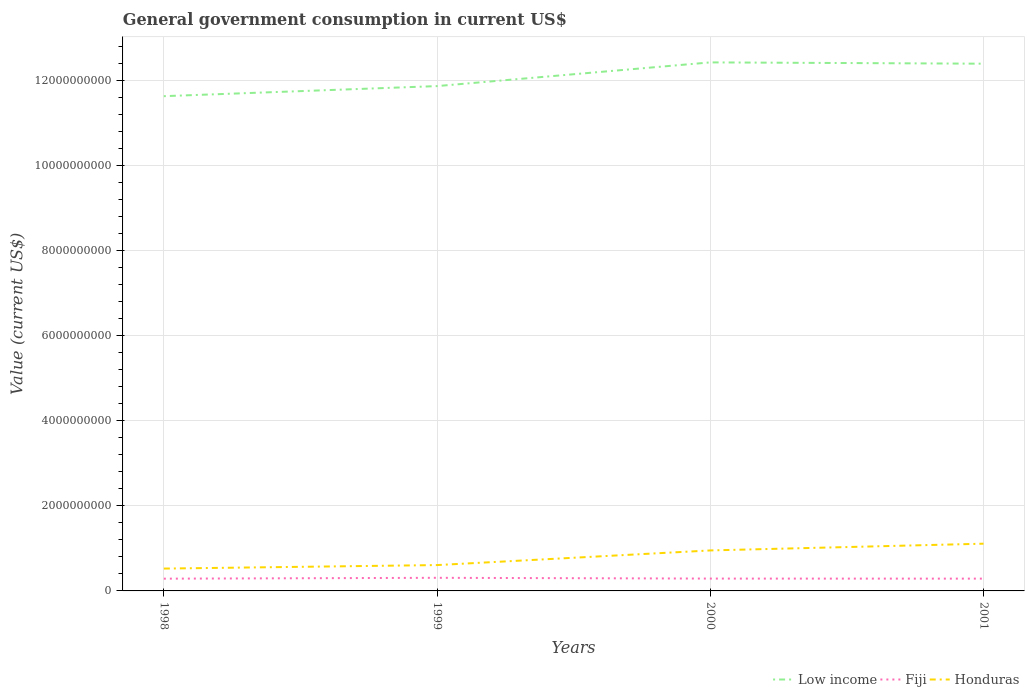Is the number of lines equal to the number of legend labels?
Your answer should be very brief. Yes. Across all years, what is the maximum government conusmption in Low income?
Offer a terse response. 1.16e+1. What is the total government conusmption in Fiji in the graph?
Your answer should be very brief. 1.83e+07. What is the difference between the highest and the second highest government conusmption in Fiji?
Keep it short and to the point. 2.03e+07. What is the difference between the highest and the lowest government conusmption in Honduras?
Offer a very short reply. 2. Does the graph contain any zero values?
Give a very brief answer. No. Does the graph contain grids?
Make the answer very short. Yes. How are the legend labels stacked?
Keep it short and to the point. Horizontal. What is the title of the graph?
Your response must be concise. General government consumption in current US$. What is the label or title of the X-axis?
Ensure brevity in your answer.  Years. What is the label or title of the Y-axis?
Provide a short and direct response. Value (current US$). What is the Value (current US$) of Low income in 1998?
Give a very brief answer. 1.16e+1. What is the Value (current US$) of Fiji in 1998?
Your response must be concise. 2.88e+08. What is the Value (current US$) in Honduras in 1998?
Provide a succinct answer. 5.26e+08. What is the Value (current US$) of Low income in 1999?
Offer a terse response. 1.19e+1. What is the Value (current US$) in Fiji in 1999?
Provide a short and direct response. 3.09e+08. What is the Value (current US$) in Honduras in 1999?
Make the answer very short. 6.08e+08. What is the Value (current US$) in Low income in 2000?
Ensure brevity in your answer.  1.24e+1. What is the Value (current US$) of Fiji in 2000?
Your answer should be very brief. 2.90e+08. What is the Value (current US$) in Honduras in 2000?
Make the answer very short. 9.53e+08. What is the Value (current US$) of Low income in 2001?
Keep it short and to the point. 1.24e+1. What is the Value (current US$) in Fiji in 2001?
Make the answer very short. 2.89e+08. What is the Value (current US$) in Honduras in 2001?
Your response must be concise. 1.11e+09. Across all years, what is the maximum Value (current US$) in Low income?
Keep it short and to the point. 1.24e+1. Across all years, what is the maximum Value (current US$) in Fiji?
Your answer should be compact. 3.09e+08. Across all years, what is the maximum Value (current US$) in Honduras?
Your answer should be very brief. 1.11e+09. Across all years, what is the minimum Value (current US$) in Low income?
Your response must be concise. 1.16e+1. Across all years, what is the minimum Value (current US$) in Fiji?
Your response must be concise. 2.88e+08. Across all years, what is the minimum Value (current US$) of Honduras?
Give a very brief answer. 5.26e+08. What is the total Value (current US$) of Low income in the graph?
Your response must be concise. 4.84e+1. What is the total Value (current US$) in Fiji in the graph?
Provide a short and direct response. 1.18e+09. What is the total Value (current US$) of Honduras in the graph?
Ensure brevity in your answer.  3.20e+09. What is the difference between the Value (current US$) in Low income in 1998 and that in 1999?
Your response must be concise. -2.37e+08. What is the difference between the Value (current US$) of Fiji in 1998 and that in 1999?
Offer a terse response. -2.03e+07. What is the difference between the Value (current US$) of Honduras in 1998 and that in 1999?
Your response must be concise. -8.25e+07. What is the difference between the Value (current US$) in Low income in 1998 and that in 2000?
Provide a succinct answer. -7.95e+08. What is the difference between the Value (current US$) in Fiji in 1998 and that in 2000?
Your response must be concise. -2.08e+06. What is the difference between the Value (current US$) of Honduras in 1998 and that in 2000?
Your response must be concise. -4.27e+08. What is the difference between the Value (current US$) of Low income in 1998 and that in 2001?
Offer a terse response. -7.64e+08. What is the difference between the Value (current US$) in Fiji in 1998 and that in 2001?
Offer a very short reply. -1.00e+06. What is the difference between the Value (current US$) in Honduras in 1998 and that in 2001?
Ensure brevity in your answer.  -5.86e+08. What is the difference between the Value (current US$) of Low income in 1999 and that in 2000?
Your answer should be compact. -5.58e+08. What is the difference between the Value (current US$) of Fiji in 1999 and that in 2000?
Offer a very short reply. 1.83e+07. What is the difference between the Value (current US$) of Honduras in 1999 and that in 2000?
Give a very brief answer. -3.45e+08. What is the difference between the Value (current US$) of Low income in 1999 and that in 2001?
Offer a very short reply. -5.27e+08. What is the difference between the Value (current US$) in Fiji in 1999 and that in 2001?
Provide a short and direct response. 1.93e+07. What is the difference between the Value (current US$) of Honduras in 1999 and that in 2001?
Give a very brief answer. -5.03e+08. What is the difference between the Value (current US$) of Low income in 2000 and that in 2001?
Your answer should be very brief. 3.06e+07. What is the difference between the Value (current US$) of Fiji in 2000 and that in 2001?
Offer a terse response. 1.08e+06. What is the difference between the Value (current US$) in Honduras in 2000 and that in 2001?
Provide a short and direct response. -1.59e+08. What is the difference between the Value (current US$) in Low income in 1998 and the Value (current US$) in Fiji in 1999?
Make the answer very short. 1.13e+1. What is the difference between the Value (current US$) of Low income in 1998 and the Value (current US$) of Honduras in 1999?
Keep it short and to the point. 1.10e+1. What is the difference between the Value (current US$) in Fiji in 1998 and the Value (current US$) in Honduras in 1999?
Provide a short and direct response. -3.20e+08. What is the difference between the Value (current US$) of Low income in 1998 and the Value (current US$) of Fiji in 2000?
Offer a very short reply. 1.13e+1. What is the difference between the Value (current US$) of Low income in 1998 and the Value (current US$) of Honduras in 2000?
Keep it short and to the point. 1.07e+1. What is the difference between the Value (current US$) of Fiji in 1998 and the Value (current US$) of Honduras in 2000?
Offer a very short reply. -6.65e+08. What is the difference between the Value (current US$) of Low income in 1998 and the Value (current US$) of Fiji in 2001?
Your answer should be very brief. 1.14e+1. What is the difference between the Value (current US$) in Low income in 1998 and the Value (current US$) in Honduras in 2001?
Offer a terse response. 1.05e+1. What is the difference between the Value (current US$) in Fiji in 1998 and the Value (current US$) in Honduras in 2001?
Provide a short and direct response. -8.23e+08. What is the difference between the Value (current US$) of Low income in 1999 and the Value (current US$) of Fiji in 2000?
Make the answer very short. 1.16e+1. What is the difference between the Value (current US$) of Low income in 1999 and the Value (current US$) of Honduras in 2000?
Offer a terse response. 1.09e+1. What is the difference between the Value (current US$) of Fiji in 1999 and the Value (current US$) of Honduras in 2000?
Make the answer very short. -6.44e+08. What is the difference between the Value (current US$) of Low income in 1999 and the Value (current US$) of Fiji in 2001?
Ensure brevity in your answer.  1.16e+1. What is the difference between the Value (current US$) of Low income in 1999 and the Value (current US$) of Honduras in 2001?
Ensure brevity in your answer.  1.08e+1. What is the difference between the Value (current US$) of Fiji in 1999 and the Value (current US$) of Honduras in 2001?
Provide a succinct answer. -8.03e+08. What is the difference between the Value (current US$) of Low income in 2000 and the Value (current US$) of Fiji in 2001?
Ensure brevity in your answer.  1.21e+1. What is the difference between the Value (current US$) of Low income in 2000 and the Value (current US$) of Honduras in 2001?
Your answer should be compact. 1.13e+1. What is the difference between the Value (current US$) of Fiji in 2000 and the Value (current US$) of Honduras in 2001?
Keep it short and to the point. -8.21e+08. What is the average Value (current US$) in Low income per year?
Provide a succinct answer. 1.21e+1. What is the average Value (current US$) of Fiji per year?
Give a very brief answer. 2.94e+08. What is the average Value (current US$) in Honduras per year?
Ensure brevity in your answer.  7.99e+08. In the year 1998, what is the difference between the Value (current US$) of Low income and Value (current US$) of Fiji?
Your answer should be compact. 1.14e+1. In the year 1998, what is the difference between the Value (current US$) in Low income and Value (current US$) in Honduras?
Your response must be concise. 1.11e+1. In the year 1998, what is the difference between the Value (current US$) in Fiji and Value (current US$) in Honduras?
Offer a terse response. -2.37e+08. In the year 1999, what is the difference between the Value (current US$) in Low income and Value (current US$) in Fiji?
Provide a succinct answer. 1.16e+1. In the year 1999, what is the difference between the Value (current US$) in Low income and Value (current US$) in Honduras?
Your answer should be very brief. 1.13e+1. In the year 1999, what is the difference between the Value (current US$) of Fiji and Value (current US$) of Honduras?
Keep it short and to the point. -3.00e+08. In the year 2000, what is the difference between the Value (current US$) of Low income and Value (current US$) of Fiji?
Offer a very short reply. 1.21e+1. In the year 2000, what is the difference between the Value (current US$) of Low income and Value (current US$) of Honduras?
Give a very brief answer. 1.15e+1. In the year 2000, what is the difference between the Value (current US$) in Fiji and Value (current US$) in Honduras?
Give a very brief answer. -6.62e+08. In the year 2001, what is the difference between the Value (current US$) in Low income and Value (current US$) in Fiji?
Offer a very short reply. 1.21e+1. In the year 2001, what is the difference between the Value (current US$) in Low income and Value (current US$) in Honduras?
Your answer should be compact. 1.13e+1. In the year 2001, what is the difference between the Value (current US$) in Fiji and Value (current US$) in Honduras?
Ensure brevity in your answer.  -8.22e+08. What is the ratio of the Value (current US$) of Low income in 1998 to that in 1999?
Your response must be concise. 0.98. What is the ratio of the Value (current US$) of Fiji in 1998 to that in 1999?
Your answer should be very brief. 0.93. What is the ratio of the Value (current US$) of Honduras in 1998 to that in 1999?
Give a very brief answer. 0.86. What is the ratio of the Value (current US$) of Low income in 1998 to that in 2000?
Offer a terse response. 0.94. What is the ratio of the Value (current US$) of Fiji in 1998 to that in 2000?
Offer a terse response. 0.99. What is the ratio of the Value (current US$) in Honduras in 1998 to that in 2000?
Keep it short and to the point. 0.55. What is the ratio of the Value (current US$) in Low income in 1998 to that in 2001?
Your response must be concise. 0.94. What is the ratio of the Value (current US$) in Honduras in 1998 to that in 2001?
Your answer should be compact. 0.47. What is the ratio of the Value (current US$) in Low income in 1999 to that in 2000?
Offer a very short reply. 0.96. What is the ratio of the Value (current US$) of Fiji in 1999 to that in 2000?
Offer a very short reply. 1.06. What is the ratio of the Value (current US$) of Honduras in 1999 to that in 2000?
Make the answer very short. 0.64. What is the ratio of the Value (current US$) of Low income in 1999 to that in 2001?
Offer a very short reply. 0.96. What is the ratio of the Value (current US$) in Fiji in 1999 to that in 2001?
Your answer should be very brief. 1.07. What is the ratio of the Value (current US$) in Honduras in 1999 to that in 2001?
Ensure brevity in your answer.  0.55. What is the ratio of the Value (current US$) in Fiji in 2000 to that in 2001?
Your answer should be very brief. 1. What is the ratio of the Value (current US$) in Honduras in 2000 to that in 2001?
Provide a succinct answer. 0.86. What is the difference between the highest and the second highest Value (current US$) in Low income?
Give a very brief answer. 3.06e+07. What is the difference between the highest and the second highest Value (current US$) in Fiji?
Your answer should be compact. 1.83e+07. What is the difference between the highest and the second highest Value (current US$) in Honduras?
Make the answer very short. 1.59e+08. What is the difference between the highest and the lowest Value (current US$) in Low income?
Your answer should be very brief. 7.95e+08. What is the difference between the highest and the lowest Value (current US$) of Fiji?
Provide a succinct answer. 2.03e+07. What is the difference between the highest and the lowest Value (current US$) in Honduras?
Keep it short and to the point. 5.86e+08. 